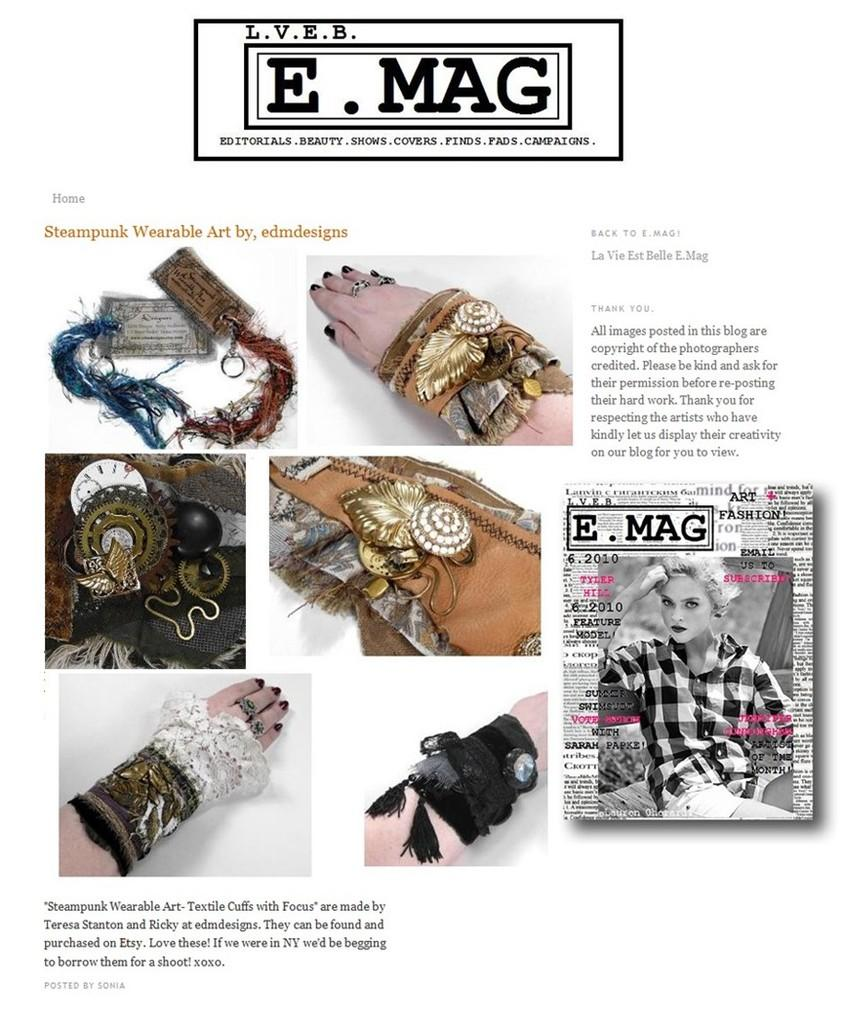What is present in the image that contains both images and text? There is a poster in the image that contains images and text. What type of trouble is depicted in the poster? There is no depiction of trouble in the poster, as it only contains images and text. 